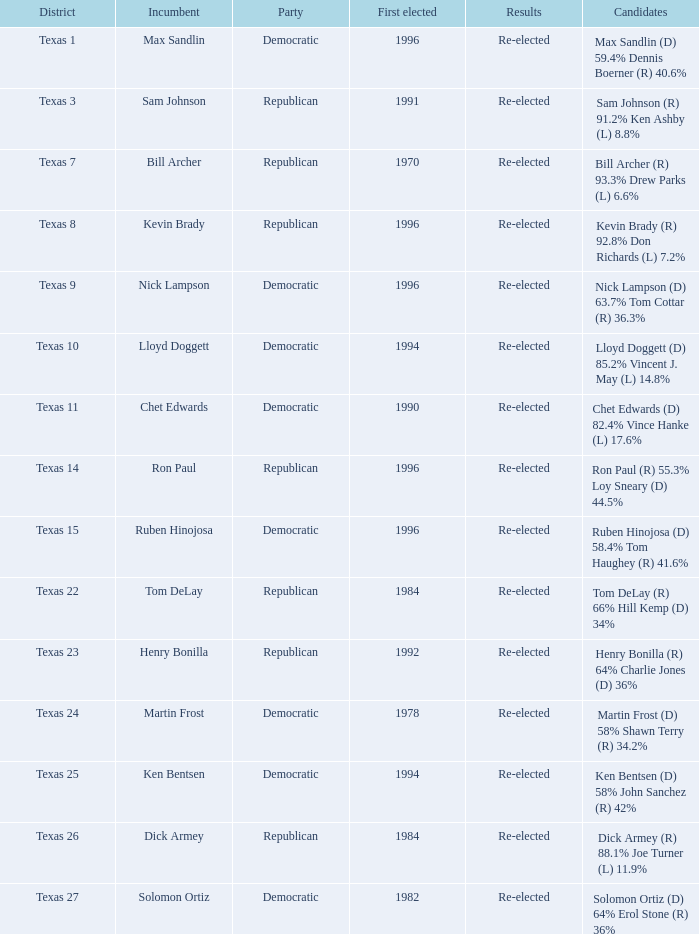What district is ruben hinojosa from? Texas 15. 